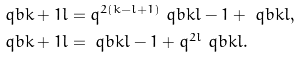Convert formula to latex. <formula><loc_0><loc_0><loc_500><loc_500>\ q b { k + 1 } { l } & = q ^ { 2 ( k - l + 1 ) } \ q b { k } { l - 1 } + \ q b { k } { l } , \\ \ q b { k + 1 } { l } & = \ q b { k } { l - 1 } + q ^ { 2 l } \ q b { k } { l } .</formula> 